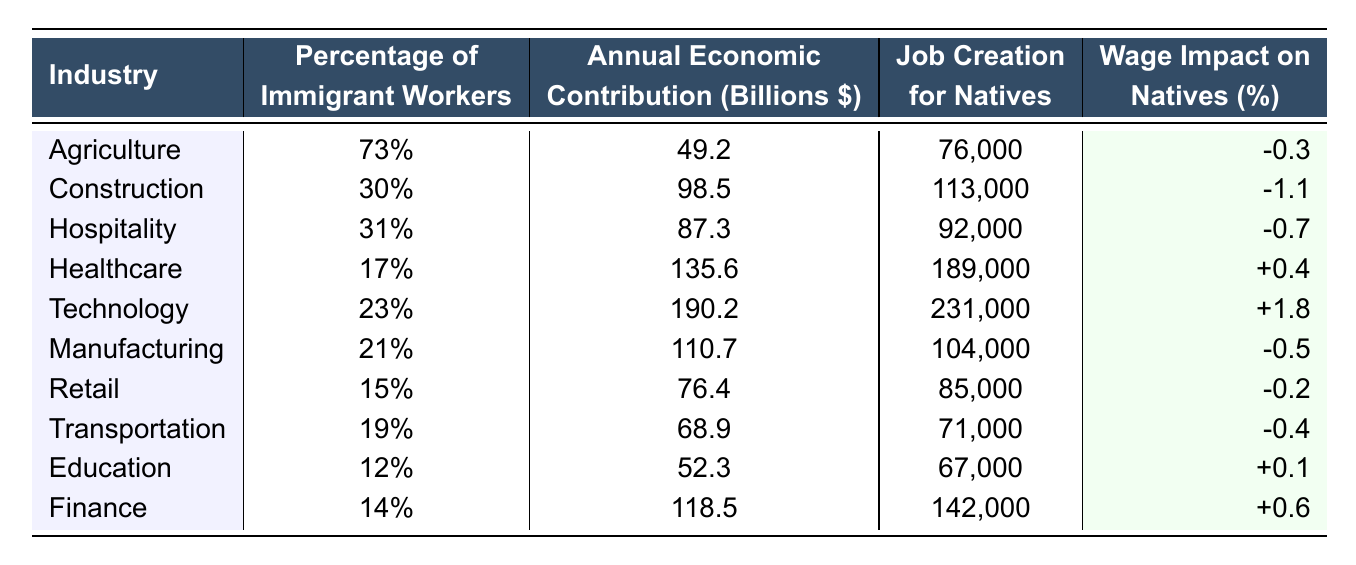What percentage of immigrant workers is in the Agriculture industry? The table shows that the Agriculture industry has 73% of its workers being immigrants.
Answer: 73% Which industry has the highest annual economic contribution in billions of dollars? By examining the table, the Technology industry has the highest annual economic contribution at 190.2 billion dollars.
Answer: 190.2 How many jobs are created for natives in the Healthcare industry? According to the table, the Healthcare industry creates 189,000 jobs for natives.
Answer: 189,000 Is the wage impact on natives in the Construction industry positive or negative? The table indicates that the wage impact on natives in the Construction industry is -1.1%, which is negative.
Answer: Negative What is the average percentage of immigrant workers across the Education and Finance industries? The Education industry has 12% and the Finance industry has 14%. Thus, the average is (12 + 14) / 2 = 13%.
Answer: 13% Which industry creates more jobs for natives, Hospitality or Transportation? The Hospitality industry creates 92,000 jobs for natives, while Transportation creates 71,000 jobs. Since 92,000 is greater than 71,000, Hospitality creates more jobs.
Answer: Hospitality What is the total annual economic contribution of the Agriculture and Manufacturing industries? The table shows that Agriculture contributes 49.2 billion dollars and Manufacturing contributes 110.7 billion dollars. The total contribution is 49.2 + 110.7 = 159.9 billion dollars.
Answer: 159.9 billion Which industry has the least percentage of immigrant workers, and what is that percentage? Education has the least percentage of immigrant workers at 12%.
Answer: 12% If the percentage of immigrant workers in the Technology industry increases by 5%, what would the new percentage be? The Technology industry currently has 23%, so increasing it by 5% results in 23 + 5 = 28%.
Answer: 28% Does the Healthcare industry have a positive or negative wage impact on natives? The table indicates that the wage impact on natives in the Healthcare industry is +0.4%, which is positive.
Answer: Positive 